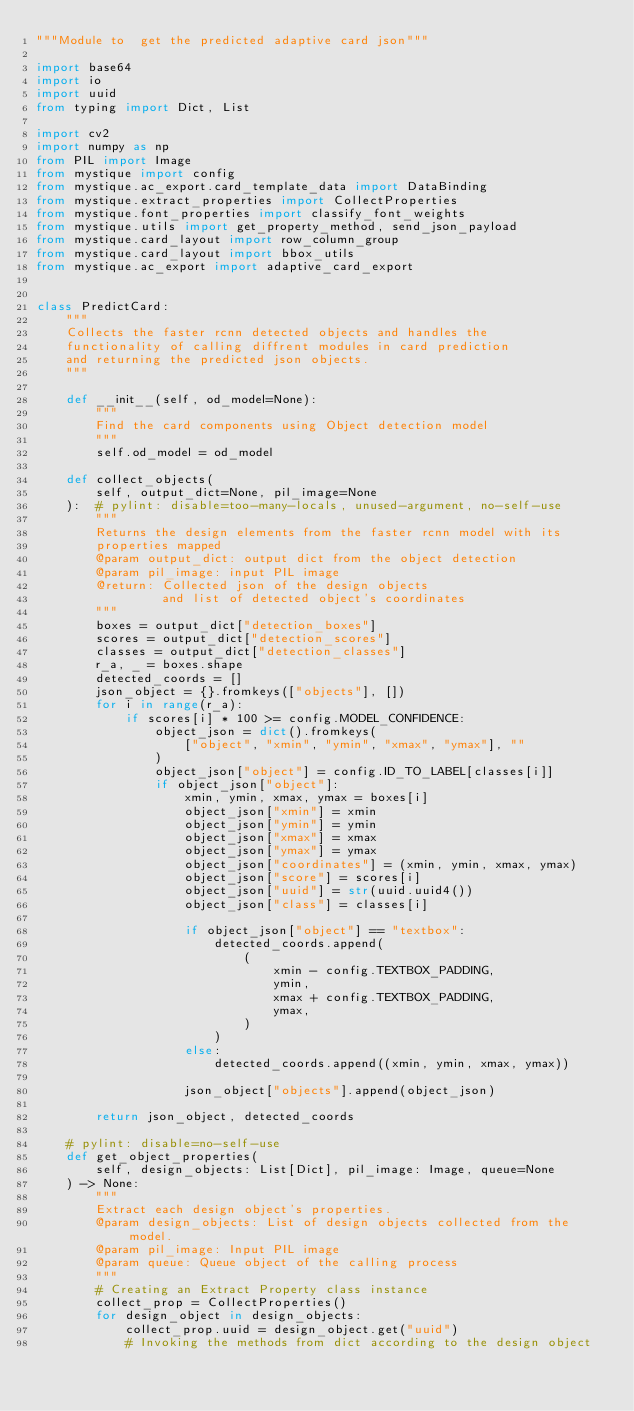<code> <loc_0><loc_0><loc_500><loc_500><_Python_>"""Module to  get the predicted adaptive card json"""

import base64
import io
import uuid
from typing import Dict, List

import cv2
import numpy as np
from PIL import Image
from mystique import config
from mystique.ac_export.card_template_data import DataBinding
from mystique.extract_properties import CollectProperties
from mystique.font_properties import classify_font_weights
from mystique.utils import get_property_method, send_json_payload
from mystique.card_layout import row_column_group
from mystique.card_layout import bbox_utils
from mystique.ac_export import adaptive_card_export


class PredictCard:
    """
    Collects the faster rcnn detected objects and handles the
    functionality of calling diffrent modules in card prediction
    and returning the predicted json objects.
    """

    def __init__(self, od_model=None):
        """
        Find the card components using Object detection model
        """
        self.od_model = od_model

    def collect_objects(
        self, output_dict=None, pil_image=None
    ):  # pylint: disable=too-many-locals, unused-argument, no-self-use
        """
        Returns the design elements from the faster rcnn model with its
        properties mapped
        @param output_dict: output dict from the object detection
        @param pil_image: input PIL image
        @return: Collected json of the design objects
                 and list of detected object's coordinates
        """
        boxes = output_dict["detection_boxes"]
        scores = output_dict["detection_scores"]
        classes = output_dict["detection_classes"]
        r_a, _ = boxes.shape
        detected_coords = []
        json_object = {}.fromkeys(["objects"], [])
        for i in range(r_a):
            if scores[i] * 100 >= config.MODEL_CONFIDENCE:
                object_json = dict().fromkeys(
                    ["object", "xmin", "ymin", "xmax", "ymax"], ""
                )
                object_json["object"] = config.ID_TO_LABEL[classes[i]]
                if object_json["object"]:
                    xmin, ymin, xmax, ymax = boxes[i]
                    object_json["xmin"] = xmin
                    object_json["ymin"] = ymin
                    object_json["xmax"] = xmax
                    object_json["ymax"] = ymax
                    object_json["coordinates"] = (xmin, ymin, xmax, ymax)
                    object_json["score"] = scores[i]
                    object_json["uuid"] = str(uuid.uuid4())
                    object_json["class"] = classes[i]

                    if object_json["object"] == "textbox":
                        detected_coords.append(
                            (
                                xmin - config.TEXTBOX_PADDING,
                                ymin,
                                xmax + config.TEXTBOX_PADDING,
                                ymax,
                            )
                        )
                    else:
                        detected_coords.append((xmin, ymin, xmax, ymax))

                    json_object["objects"].append(object_json)

        return json_object, detected_coords

    # pylint: disable=no-self-use
    def get_object_properties(
        self, design_objects: List[Dict], pil_image: Image, queue=None
    ) -> None:
        """
        Extract each design object's properties.
        @param design_objects: List of design objects collected from the model.
        @param pil_image: Input PIL image
        @param queue: Queue object of the calling process
        """
        # Creating an Extract Property class instance
        collect_prop = CollectProperties()
        for design_object in design_objects:
            collect_prop.uuid = design_object.get("uuid")
            # Invoking the methods from dict according to the design object</code> 